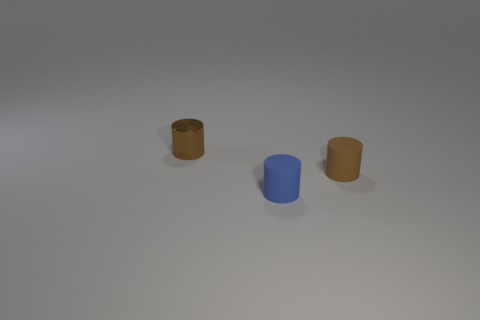What is the color of the object that is made of the same material as the blue cylinder?
Ensure brevity in your answer.  Brown. Is the tiny brown shiny thing the same shape as the blue matte object?
Offer a very short reply. Yes. How many tiny cylinders are both left of the blue object and in front of the small brown shiny cylinder?
Offer a terse response. 0. How many rubber objects are large purple spheres or small brown things?
Offer a terse response. 1. What is the size of the brown rubber cylinder in front of the brown shiny object behind the blue matte thing?
Give a very brief answer. Small. What material is the object that is the same color as the metallic cylinder?
Provide a succinct answer. Rubber. There is a small rubber cylinder in front of the thing right of the small blue rubber thing; are there any brown shiny things in front of it?
Make the answer very short. No. Is the brown cylinder that is on the right side of the small metallic thing made of the same material as the tiny brown cylinder that is left of the blue thing?
Provide a succinct answer. No. How many things are tiny purple matte objects or small matte things on the left side of the brown matte cylinder?
Your answer should be compact. 1. What number of tiny brown rubber objects have the same shape as the blue rubber thing?
Give a very brief answer. 1. 